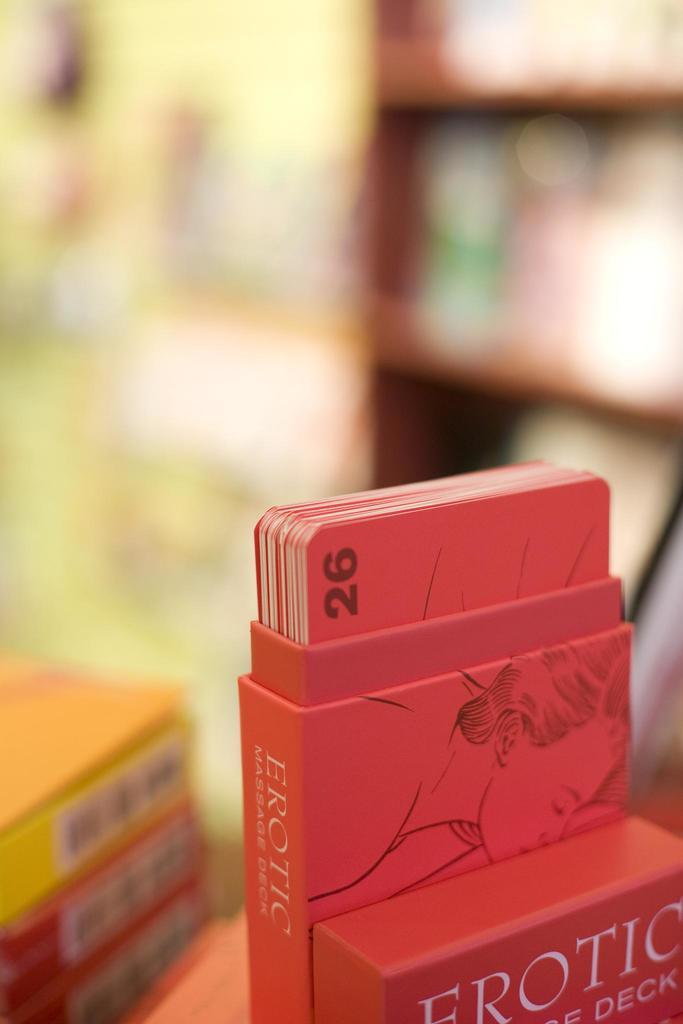<image>
Relay a brief, clear account of the picture shown. a red deck of erotic cards showing number 26 at the top 